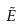Convert formula to latex. <formula><loc_0><loc_0><loc_500><loc_500>\tilde { E }</formula> 